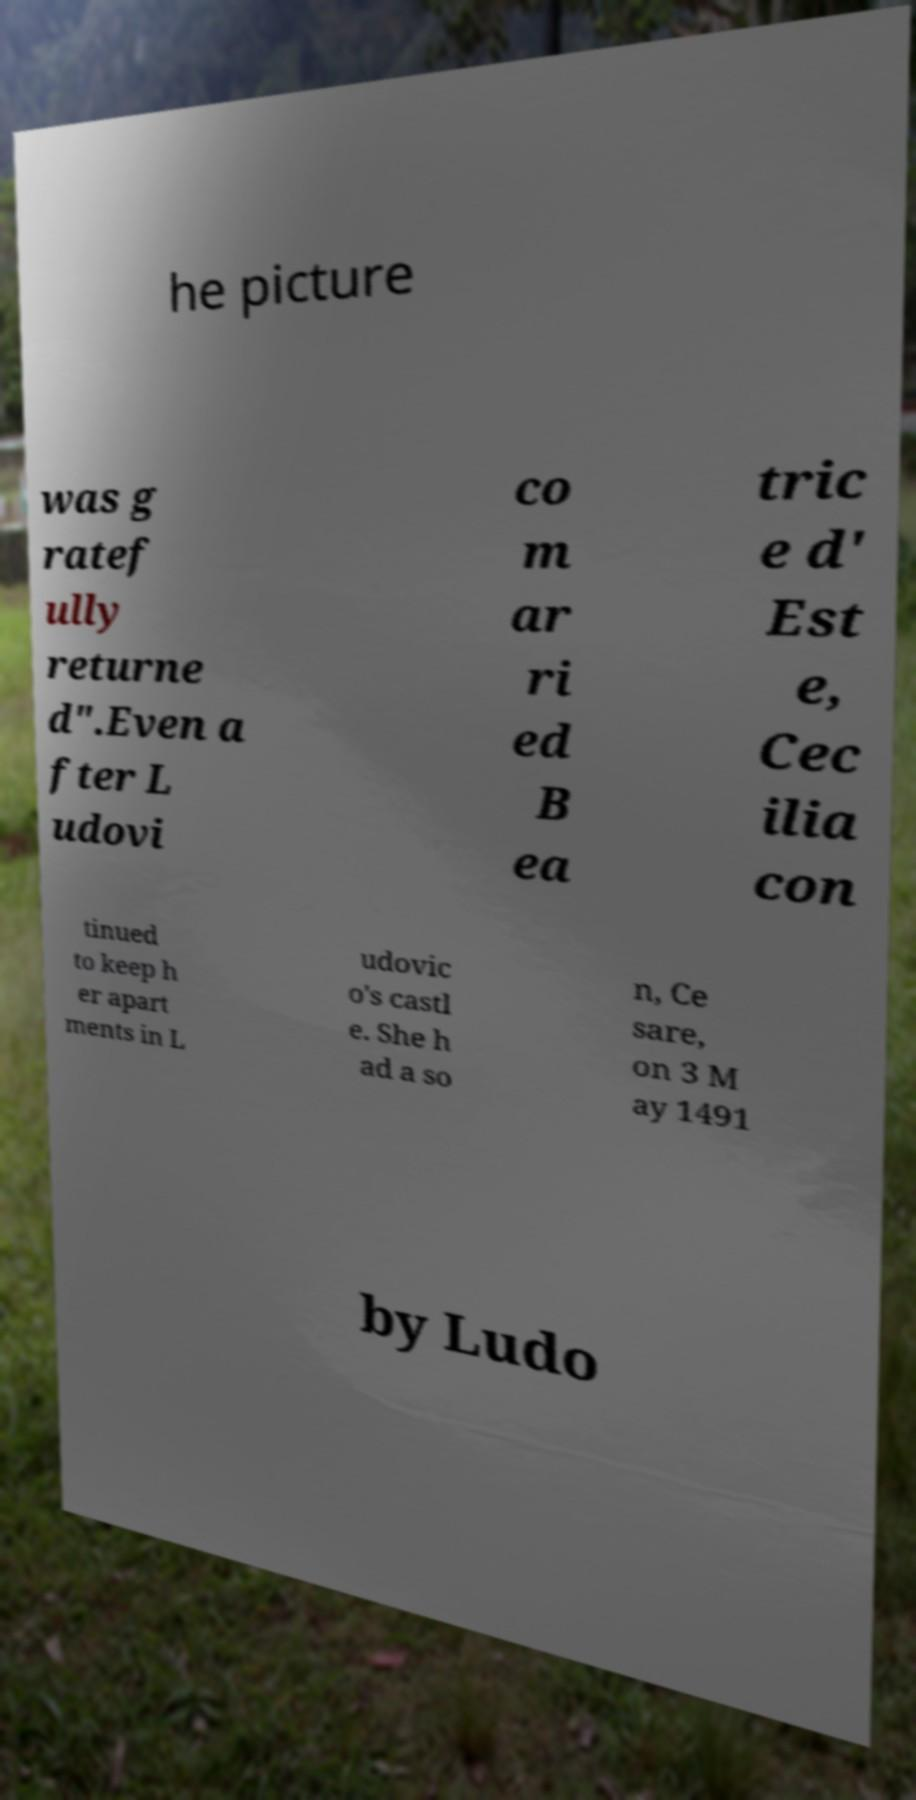Can you accurately transcribe the text from the provided image for me? he picture was g ratef ully returne d".Even a fter L udovi co m ar ri ed B ea tric e d' Est e, Cec ilia con tinued to keep h er apart ments in L udovic o's castl e. She h ad a so n, Ce sare, on 3 M ay 1491 by Ludo 